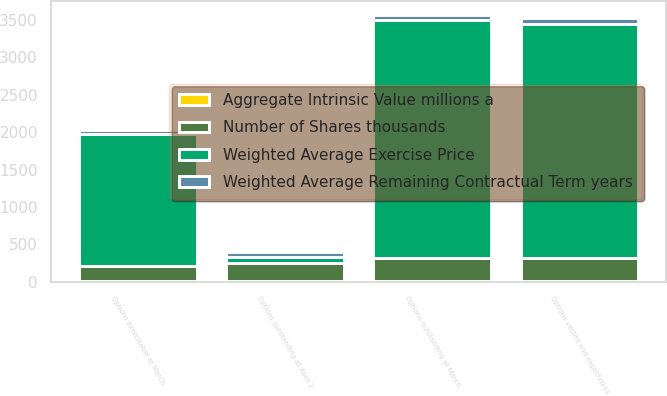Convert chart to OTSL. <chart><loc_0><loc_0><loc_500><loc_500><stacked_bar_chart><ecel><fcel>Options outstanding at April 2<fcel>Options outstanding at March<fcel>Options vested and expected to<fcel>Options exercisable at March<nl><fcel>Weighted Average Exercise Price<fcel>74.75<fcel>3178<fcel>3134<fcel>1767<nl><fcel>Weighted Average Remaining Contractual Term years<fcel>60.91<fcel>74.75<fcel>74.11<fcel>57.51<nl><fcel>Aggregate Intrinsic Value millions a<fcel>4.7<fcel>4.3<fcel>4.3<fcel>3.4<nl><fcel>Number of Shares thousands<fcel>250<fcel>316.4<fcel>314.1<fcel>206.4<nl></chart> 